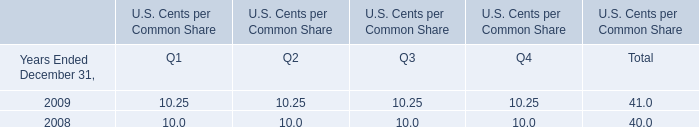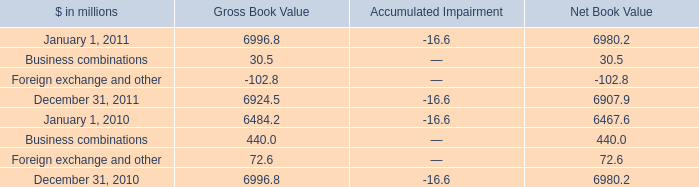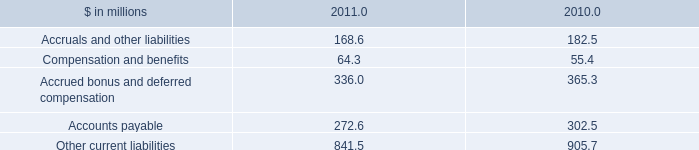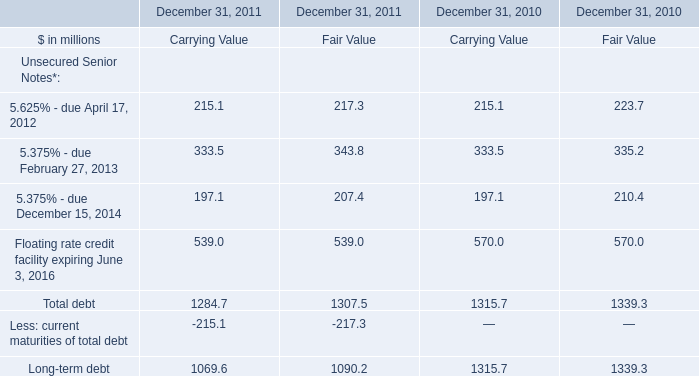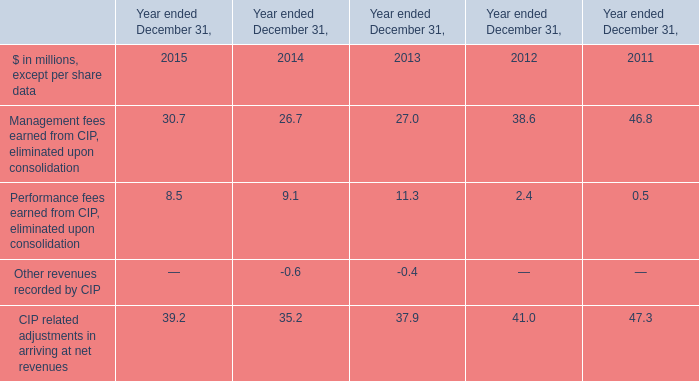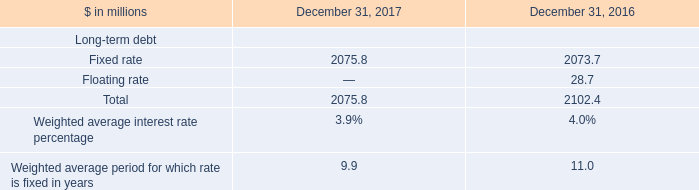Which year is 5.625% - due April 17, 2012 the highest? 
Answer: 2010. 